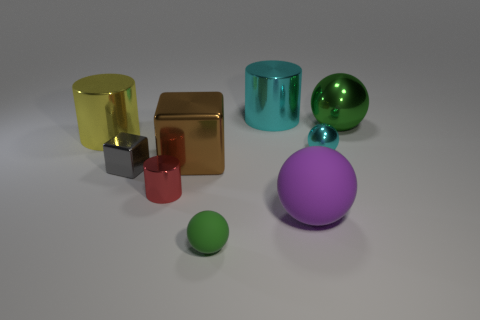Do the small metal sphere and the small metal cylinder have the same color?
Your answer should be very brief. No. Are there any tiny cyan spheres made of the same material as the big purple ball?
Your response must be concise. No. What is the color of the object that is right of the small shiny object to the right of the green ball in front of the tiny red metallic thing?
Provide a short and direct response. Green. How many yellow things are either small cubes or large metallic cylinders?
Provide a succinct answer. 1. What number of small green matte objects are the same shape as the large yellow shiny thing?
Provide a succinct answer. 0. What shape is the green object that is the same size as the cyan shiny ball?
Your answer should be very brief. Sphere. Are there any brown cubes in front of the cyan shiny sphere?
Your response must be concise. Yes. Are there any big purple objects left of the large cylinder that is in front of the large metallic sphere?
Offer a very short reply. No. Are there fewer large yellow metal cylinders that are on the right side of the green metallic ball than rubber objects behind the tiny green rubber ball?
Give a very brief answer. Yes. What shape is the green shiny thing?
Provide a short and direct response. Sphere. 